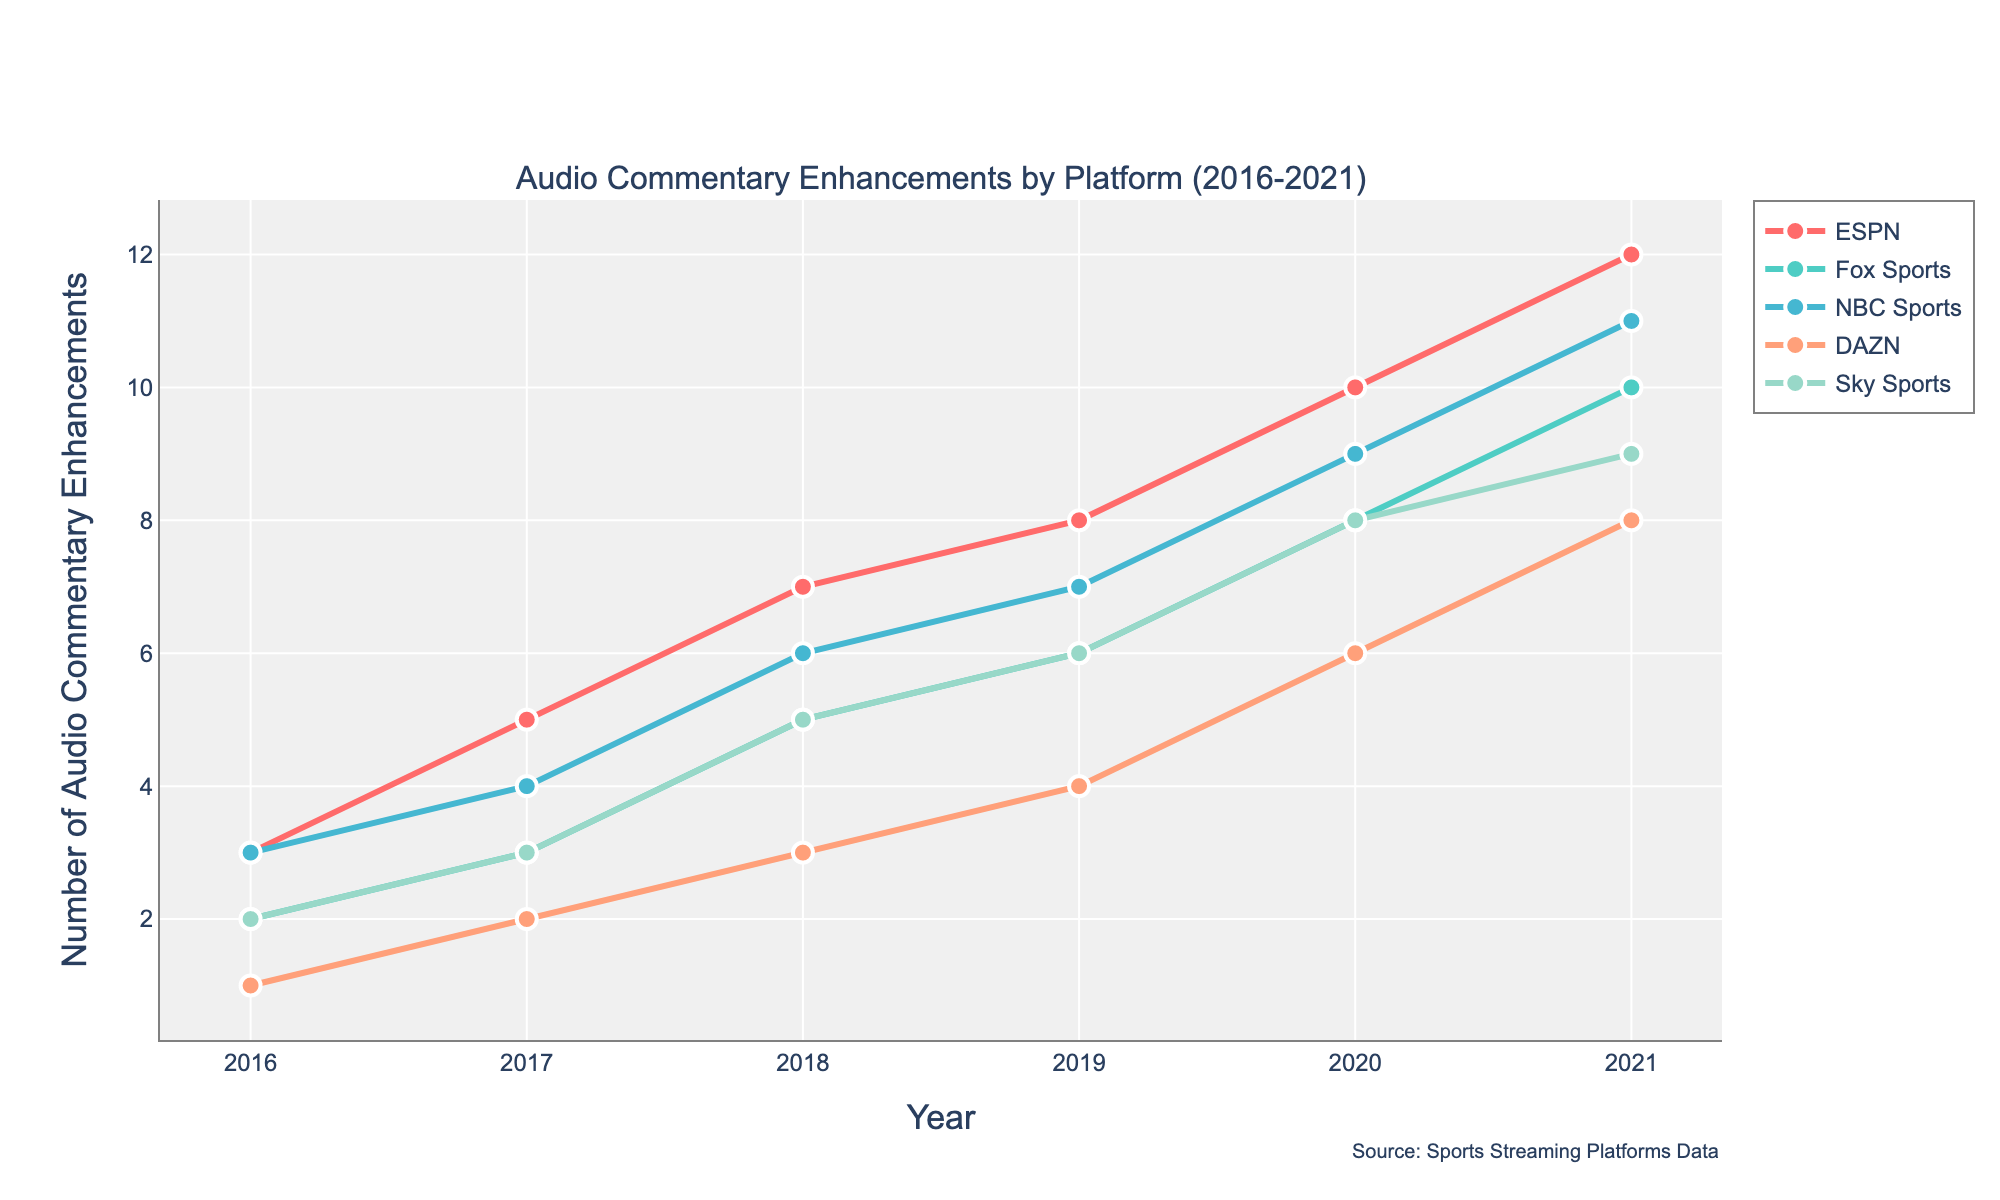Which platform had the highest number of audio commentary enhancements in 2021? Looking at the data for 2021, ESPN had the highest number of audio commentary enhancements with a count of 12.
Answer: ESPN How many audio commentary enhancements did DAZN have in 2016? From the data for the year 2016, DAZN had 1 audio commentary enhancement.
Answer: 1 Which year showed the most significant increase in audio commentary enhancements for ESPN? Comparing the yearly enhancements for ESPN, the most significant increase occurred between 2019 and 2020, increasing from 8 to 10 enhancements.
Answer: 2019 to 2020 What is the total number of audio commentary enhancements for NBC Sports across all years? Summing up the values for NBC Sports: 3 (2016) + 4 (2017) + 6 (2018) + 7 (2019) + 9 (2020) + 11 (2021) equals 40 enhancements.
Answer: 40 Which two platforms showed the same number of enhancements in 2017? From the 2017 data, Fox Sports and Sky Sports both had 3 audio commentary enhancements.
Answer: Fox Sports and Sky Sports How does the number of audio commentary enhancements for Fox Sports in 2020 compare to that in 2016? In 2020, Fox Sports had 8 enhancements, while in 2016, it had 2 enhancements, showing an increase of 6 enhancements over the period.
Answer: Increased by 6 What is the average number of audio commentary enhancements for Sky Sports between 2016 and 2021? Adding the numbers for Sky Sports: 2 (2016) + 3 (2017) + 5 (2018) + 6 (2019) + 8 (2020) + 9 (2021) gives 33. Dividing by 6 years gives an average of 5.5.
Answer: 5.5 Which platform had the lowest count of audio commentary enhancements in 2019? In 2019, DAZN had the lowest count with 4 enhancements.
Answer: DAZN How did the total count of audio commentary enhancements for ESPN change from 2016 to 2021? ESPN increased its enhancements from 3 in 2016 to 12 in 2021, a change of 9 enhancements.
Answer: Increased by 9 Which year did all platforms show an increase in audio commentary enhancements compared to the previous year? Comparing all platforms from year to year, in 2018 every platform showed an increase compared to 2017.
Answer: 2018 